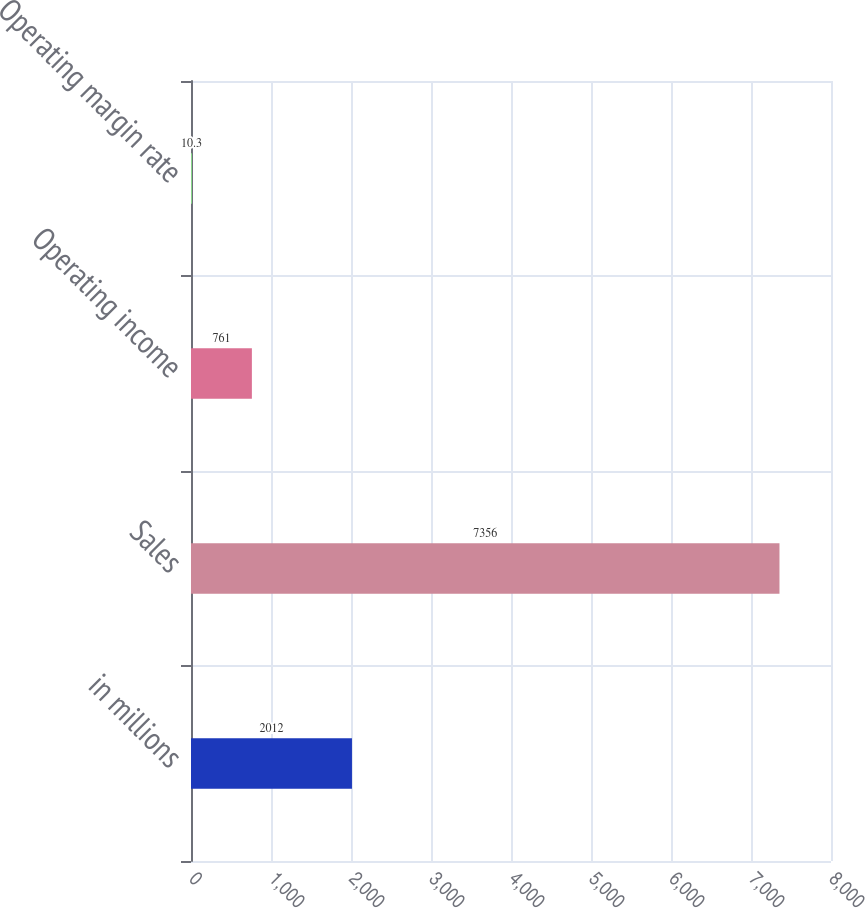Convert chart to OTSL. <chart><loc_0><loc_0><loc_500><loc_500><bar_chart><fcel>in millions<fcel>Sales<fcel>Operating income<fcel>Operating margin rate<nl><fcel>2012<fcel>7356<fcel>761<fcel>10.3<nl></chart> 